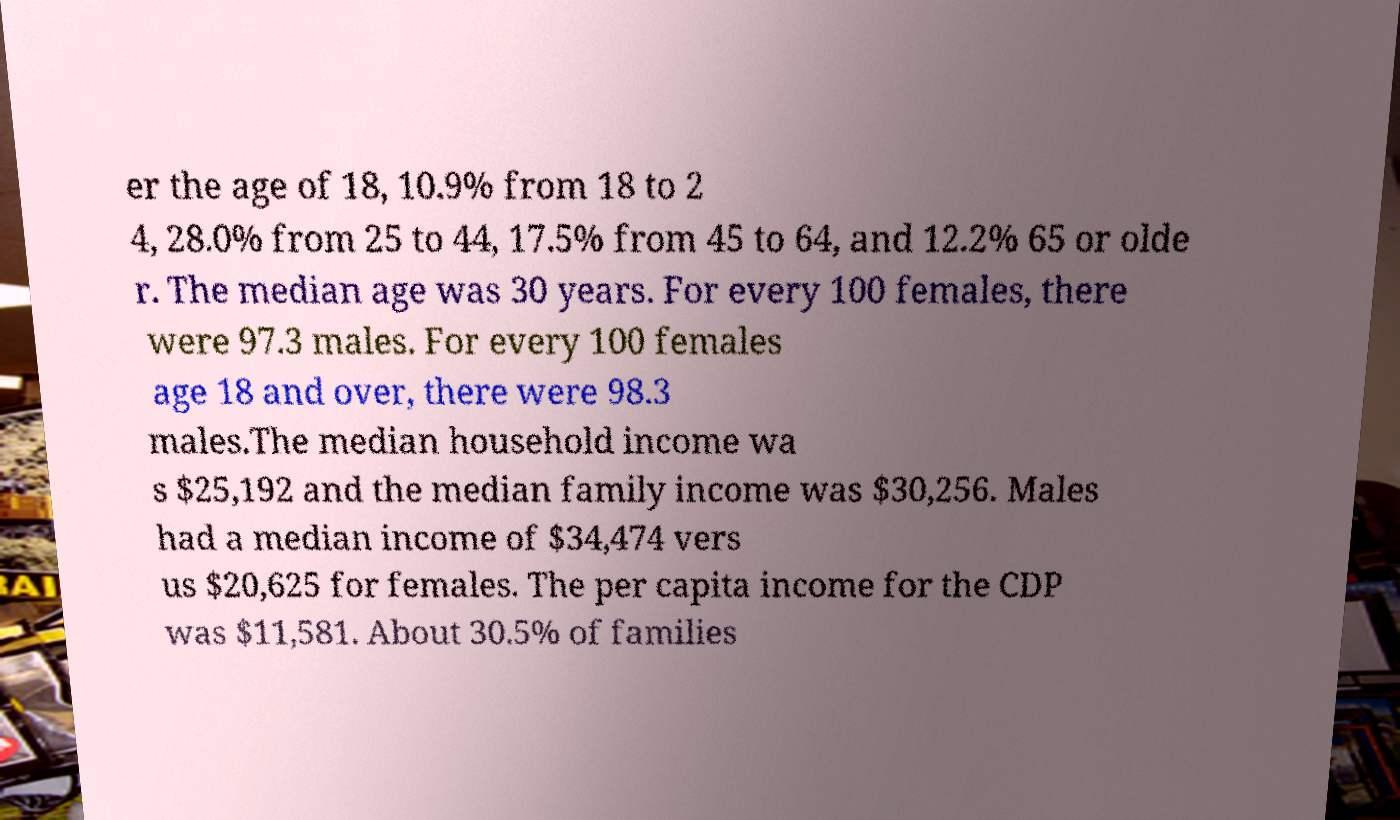What messages or text are displayed in this image? I need them in a readable, typed format. er the age of 18, 10.9% from 18 to 2 4, 28.0% from 25 to 44, 17.5% from 45 to 64, and 12.2% 65 or olde r. The median age was 30 years. For every 100 females, there were 97.3 males. For every 100 females age 18 and over, there were 98.3 males.The median household income wa s $25,192 and the median family income was $30,256. Males had a median income of $34,474 vers us $20,625 for females. The per capita income for the CDP was $11,581. About 30.5% of families 